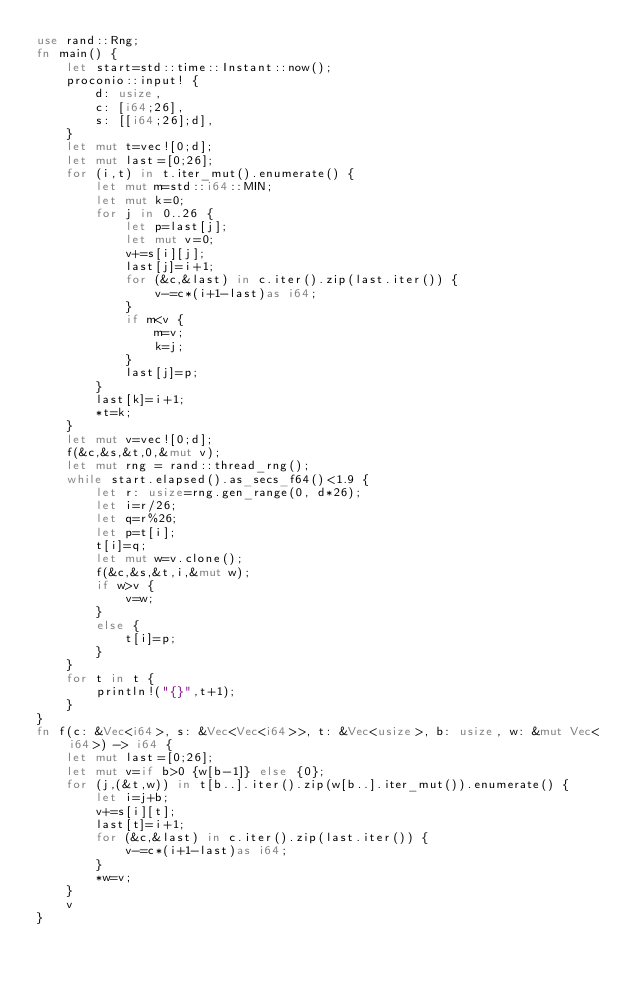Convert code to text. <code><loc_0><loc_0><loc_500><loc_500><_Rust_>use rand::Rng;
fn main() {
    let start=std::time::Instant::now();
    proconio::input! {
        d: usize,
        c: [i64;26],
        s: [[i64;26];d],
    }
    let mut t=vec![0;d];
    let mut last=[0;26];
    for (i,t) in t.iter_mut().enumerate() {
        let mut m=std::i64::MIN;
        let mut k=0;
        for j in 0..26 {
            let p=last[j];
            let mut v=0;
            v+=s[i][j];
            last[j]=i+1;
            for (&c,&last) in c.iter().zip(last.iter()) {
                v-=c*(i+1-last)as i64;
            }
            if m<v {
                m=v;
                k=j;
            }
            last[j]=p;
        }
        last[k]=i+1;
        *t=k;
    }
    let mut v=vec![0;d];
    f(&c,&s,&t,0,&mut v);
    let mut rng = rand::thread_rng();
    while start.elapsed().as_secs_f64()<1.9 {
        let r: usize=rng.gen_range(0, d*26);
        let i=r/26;
        let q=r%26;
        let p=t[i];
        t[i]=q;
        let mut w=v.clone();
        f(&c,&s,&t,i,&mut w);
        if w>v {
            v=w;
        }
        else {
            t[i]=p;
        }
    }
    for t in t {
        println!("{}",t+1);
    }
}
fn f(c: &Vec<i64>, s: &Vec<Vec<i64>>, t: &Vec<usize>, b: usize, w: &mut Vec<i64>) -> i64 {
    let mut last=[0;26];
    let mut v=if b>0 {w[b-1]} else {0};
    for (j,(&t,w)) in t[b..].iter().zip(w[b..].iter_mut()).enumerate() {
        let i=j+b;
        v+=s[i][t];
        last[t]=i+1;
        for (&c,&last) in c.iter().zip(last.iter()) {
            v-=c*(i+1-last)as i64;
        }
        *w=v;
    }
    v
}</code> 